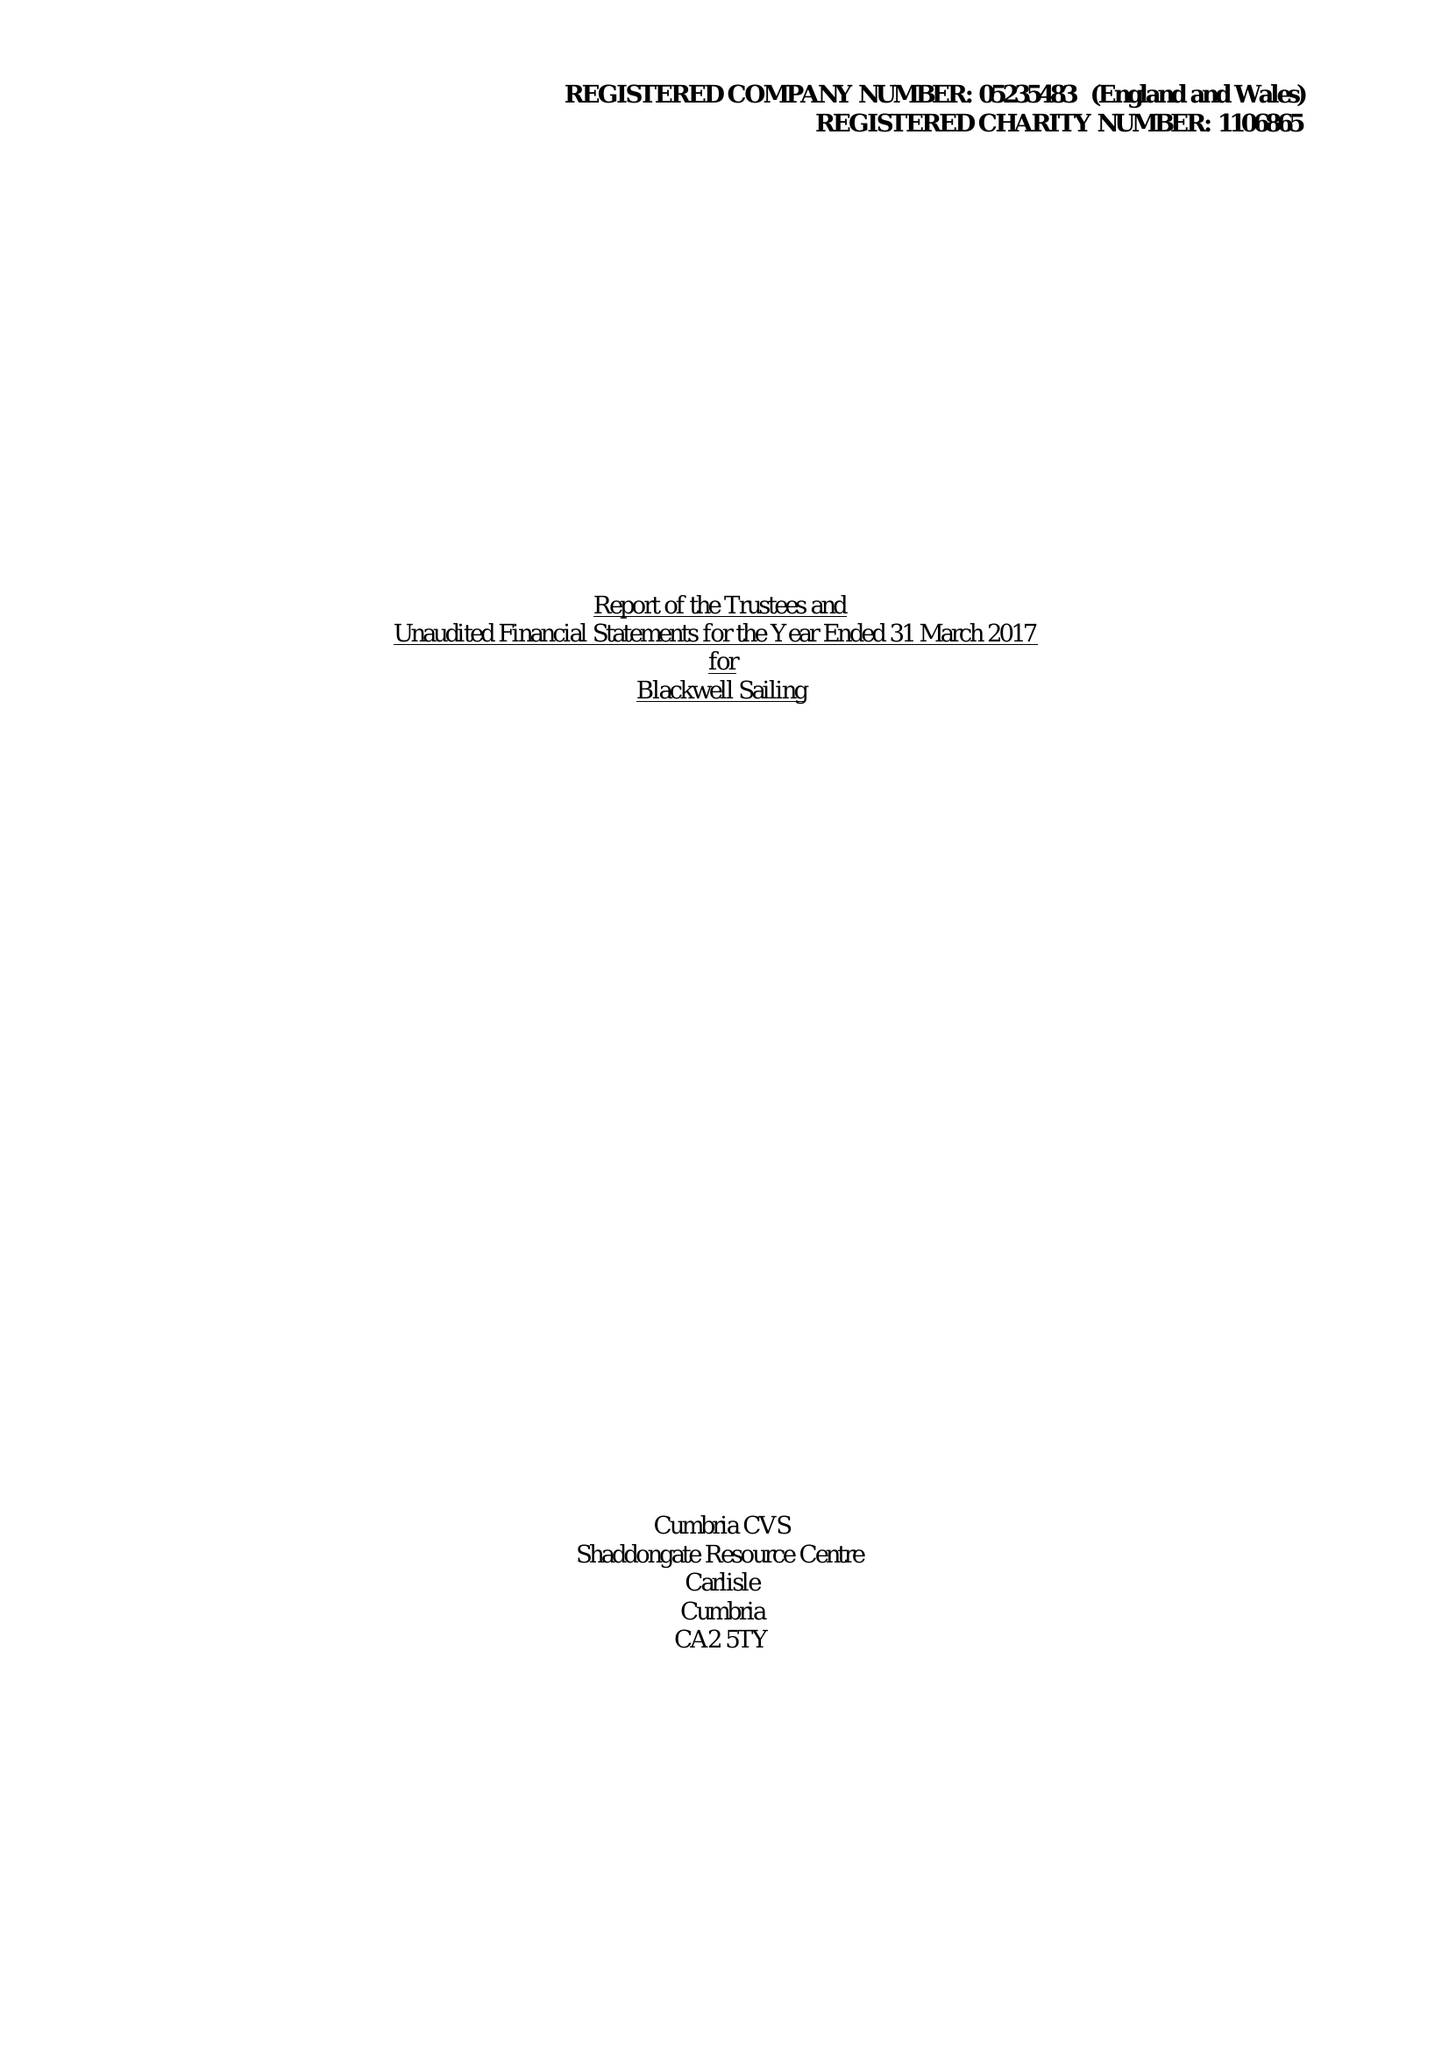What is the value for the income_annually_in_british_pounds?
Answer the question using a single word or phrase. 60816.00 